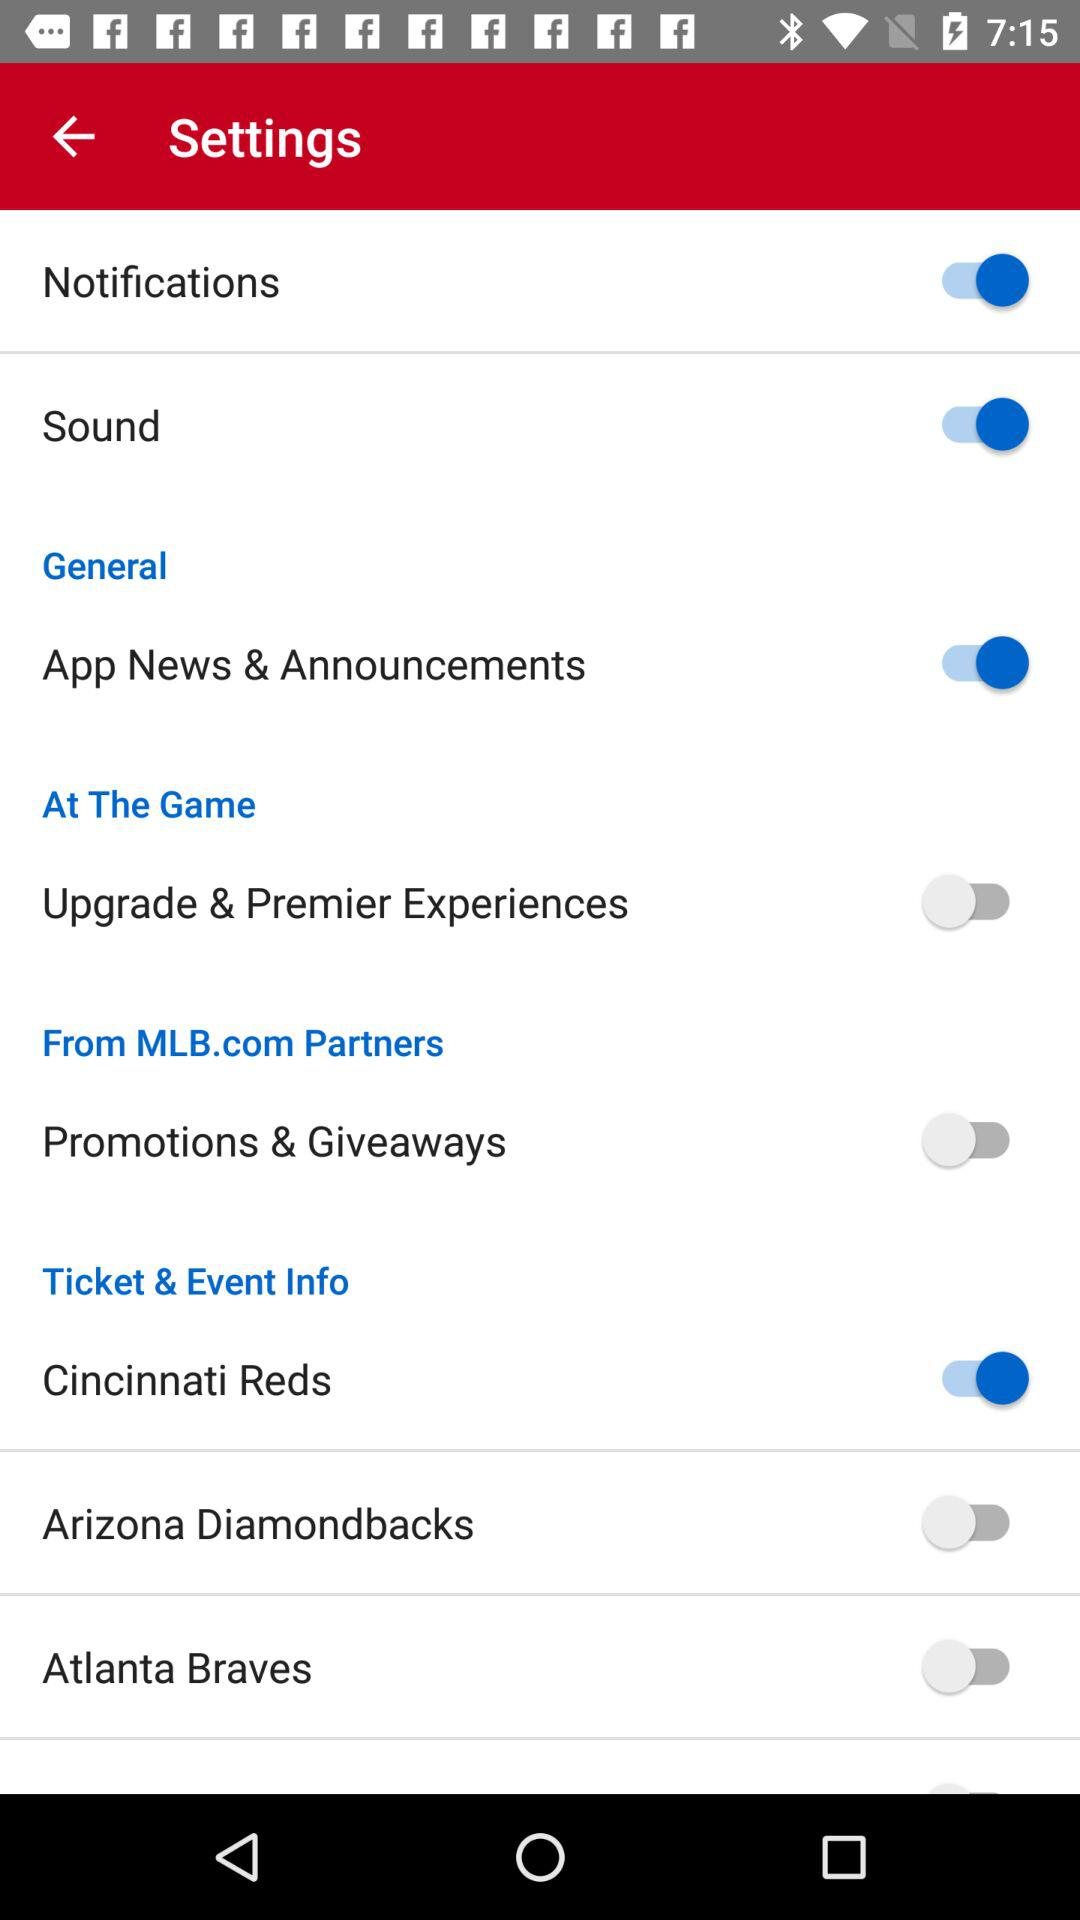What is the status of "Sound"? The status is "on". 